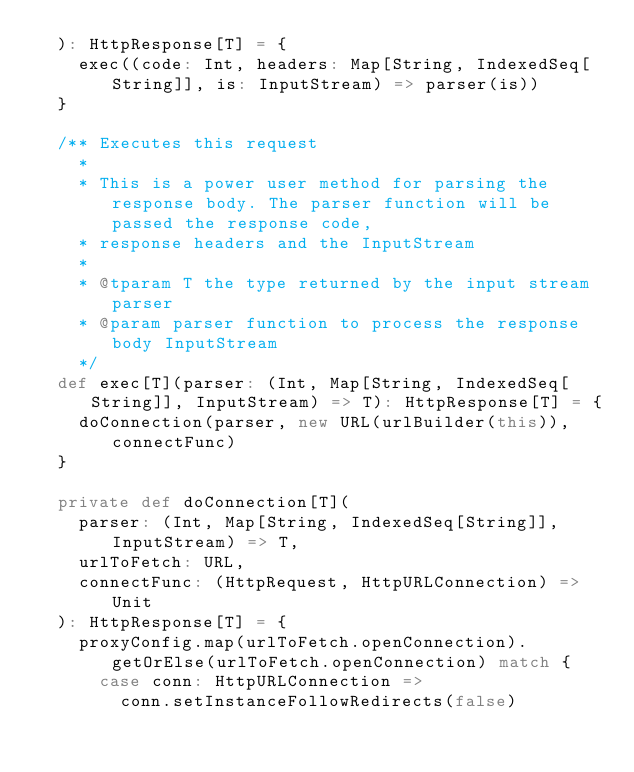<code> <loc_0><loc_0><loc_500><loc_500><_Scala_>  ): HttpResponse[T] = {
    exec((code: Int, headers: Map[String, IndexedSeq[String]], is: InputStream) => parser(is))
  }

  /** Executes this request
    *
    * This is a power user method for parsing the response body. The parser function will be passed the response code,
    * response headers and the InputStream
    *
    * @tparam T the type returned by the input stream parser
    * @param parser function to process the response body InputStream
    */
  def exec[T](parser: (Int, Map[String, IndexedSeq[String]], InputStream) => T): HttpResponse[T] = {
    doConnection(parser, new URL(urlBuilder(this)), connectFunc)
  }

  private def doConnection[T](
    parser: (Int, Map[String, IndexedSeq[String]], InputStream) => T,
    urlToFetch: URL,
    connectFunc: (HttpRequest, HttpURLConnection) => Unit
  ): HttpResponse[T] = {
    proxyConfig.map(urlToFetch.openConnection).getOrElse(urlToFetch.openConnection) match {
      case conn: HttpURLConnection =>
        conn.setInstanceFollowRedirects(false)</code> 